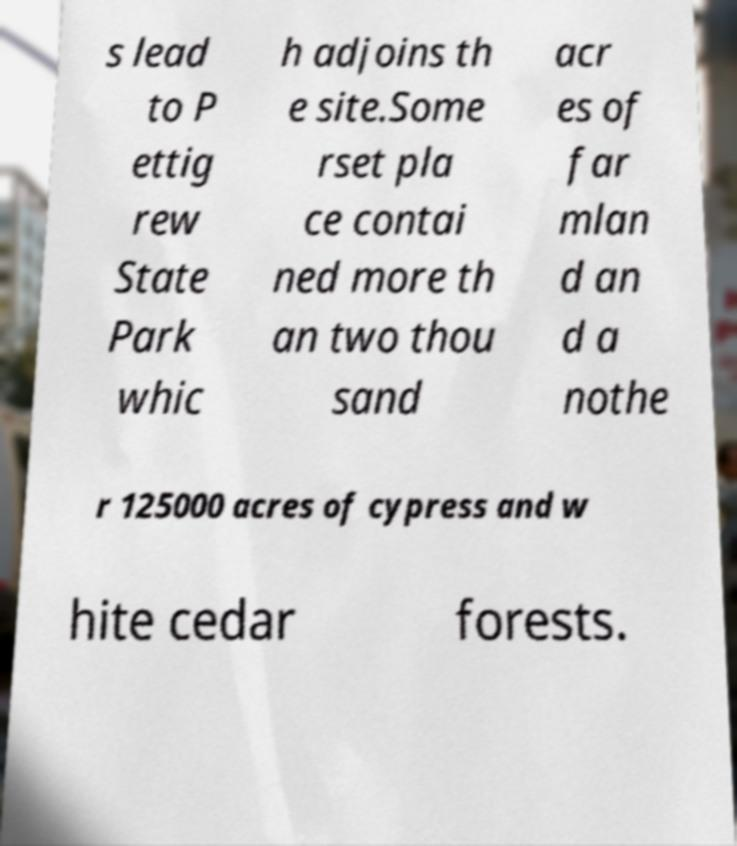Can you accurately transcribe the text from the provided image for me? s lead to P ettig rew State Park whic h adjoins th e site.Some rset pla ce contai ned more th an two thou sand acr es of far mlan d an d a nothe r 125000 acres of cypress and w hite cedar forests. 